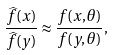<formula> <loc_0><loc_0><loc_500><loc_500>\frac { \widehat { f } ( x ) } { \widehat { f } ( y ) } \approx \frac { f ( x , \theta ) } { f ( y , \theta ) } ,</formula> 